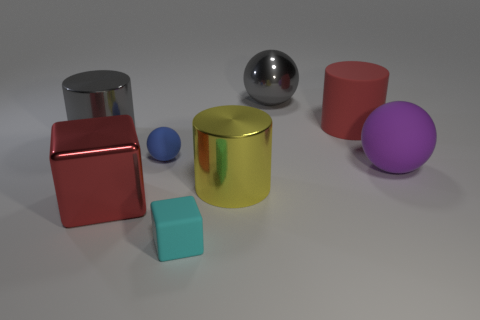Add 2 big cylinders. How many objects exist? 10 Subtract all cubes. How many objects are left? 6 Subtract 0 cyan cylinders. How many objects are left? 8 Subtract all large green shiny cubes. Subtract all big yellow metal cylinders. How many objects are left? 7 Add 8 large gray metal things. How many large gray metal things are left? 10 Add 7 purple rubber objects. How many purple rubber objects exist? 8 